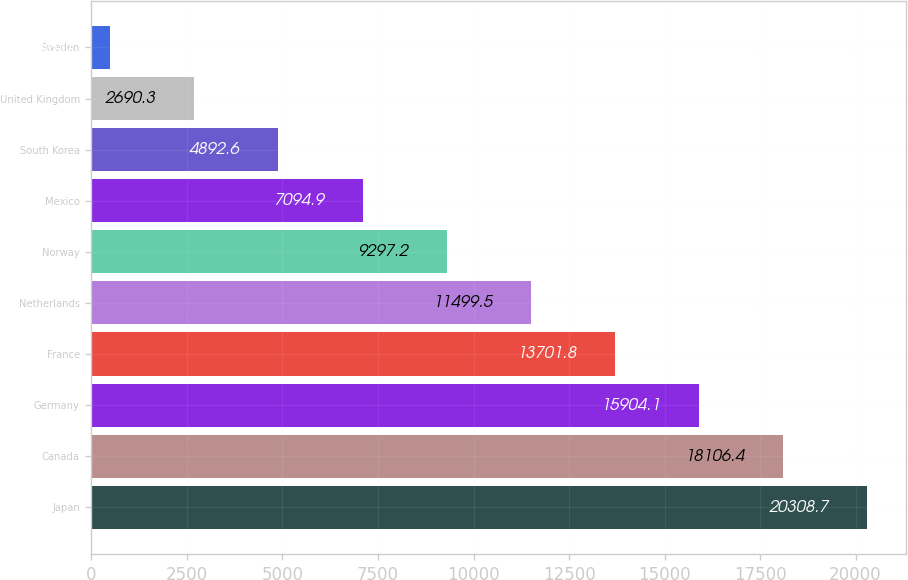Convert chart. <chart><loc_0><loc_0><loc_500><loc_500><bar_chart><fcel>Japan<fcel>Canada<fcel>Germany<fcel>France<fcel>Netherlands<fcel>Norway<fcel>Mexico<fcel>South Korea<fcel>United Kingdom<fcel>Sweden<nl><fcel>20308.7<fcel>18106.4<fcel>15904.1<fcel>13701.8<fcel>11499.5<fcel>9297.2<fcel>7094.9<fcel>4892.6<fcel>2690.3<fcel>488<nl></chart> 